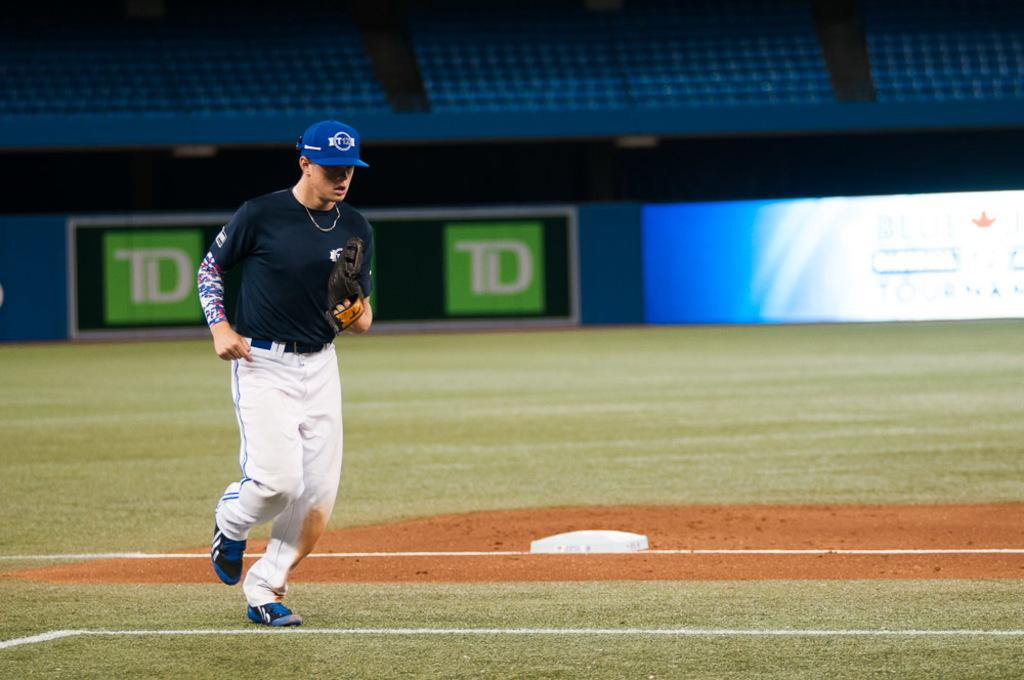<image>
Summarize the visual content of the image. A baseball player running wearing a blue hat that says ET 12 